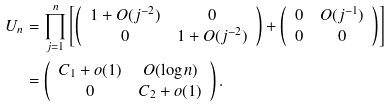Convert formula to latex. <formula><loc_0><loc_0><loc_500><loc_500>U _ { n } & = \prod _ { j = 1 } ^ { n } \left [ \left ( \begin{array} { c c } 1 + O ( j ^ { - 2 } ) & 0 \\ 0 & 1 + O ( j ^ { - 2 } ) \end{array} \right ) + \left ( \begin{array} { c c } 0 & O ( j ^ { - 1 } ) \\ 0 & 0 \end{array} \right ) \right ] \\ & = \left ( \begin{array} { c c } C _ { 1 } + o ( 1 ) & O ( \log n ) \\ 0 & C _ { 2 } + o ( 1 ) \end{array} \right ) .</formula> 